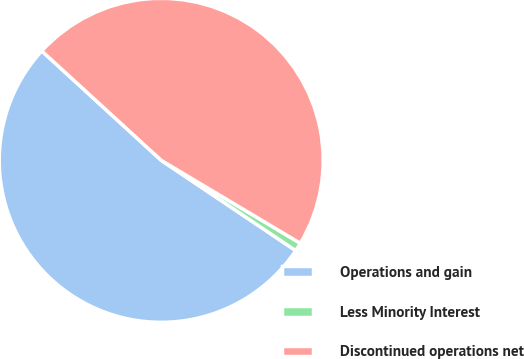<chart> <loc_0><loc_0><loc_500><loc_500><pie_chart><fcel>Operations and gain<fcel>Less Minority Interest<fcel>Discontinued operations net<nl><fcel>52.39%<fcel>0.85%<fcel>46.76%<nl></chart> 